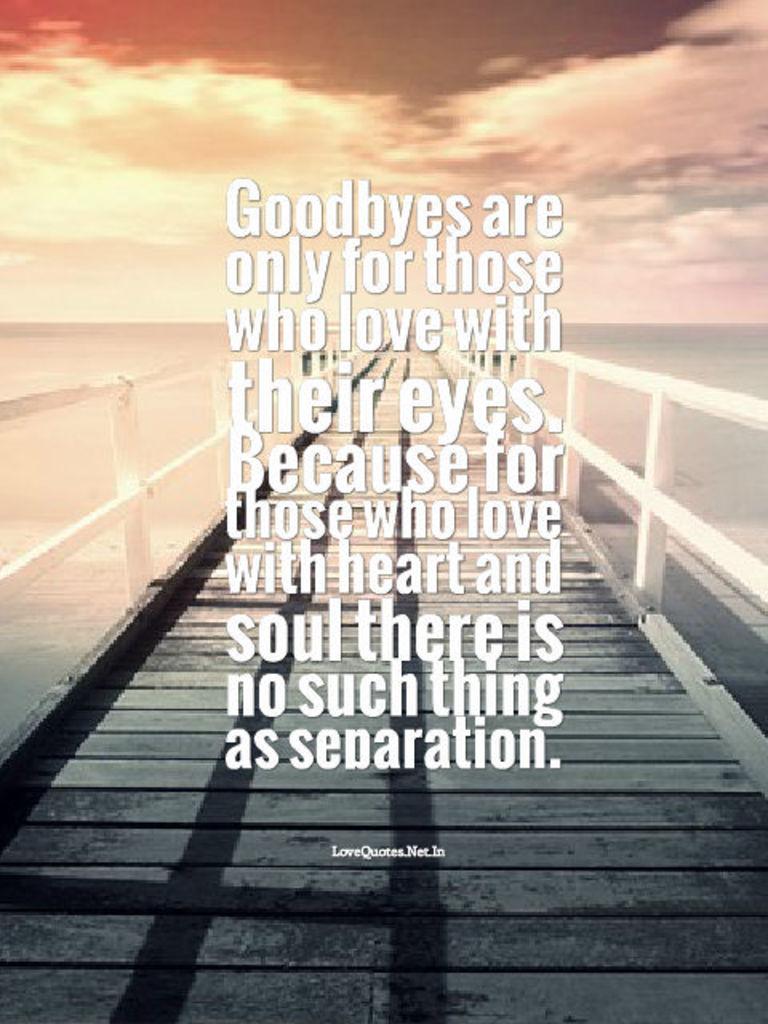Is there such thing as separation for those who love with the soul?
Ensure brevity in your answer.  No. What is the first word here?
Keep it short and to the point. Goodbyes. 